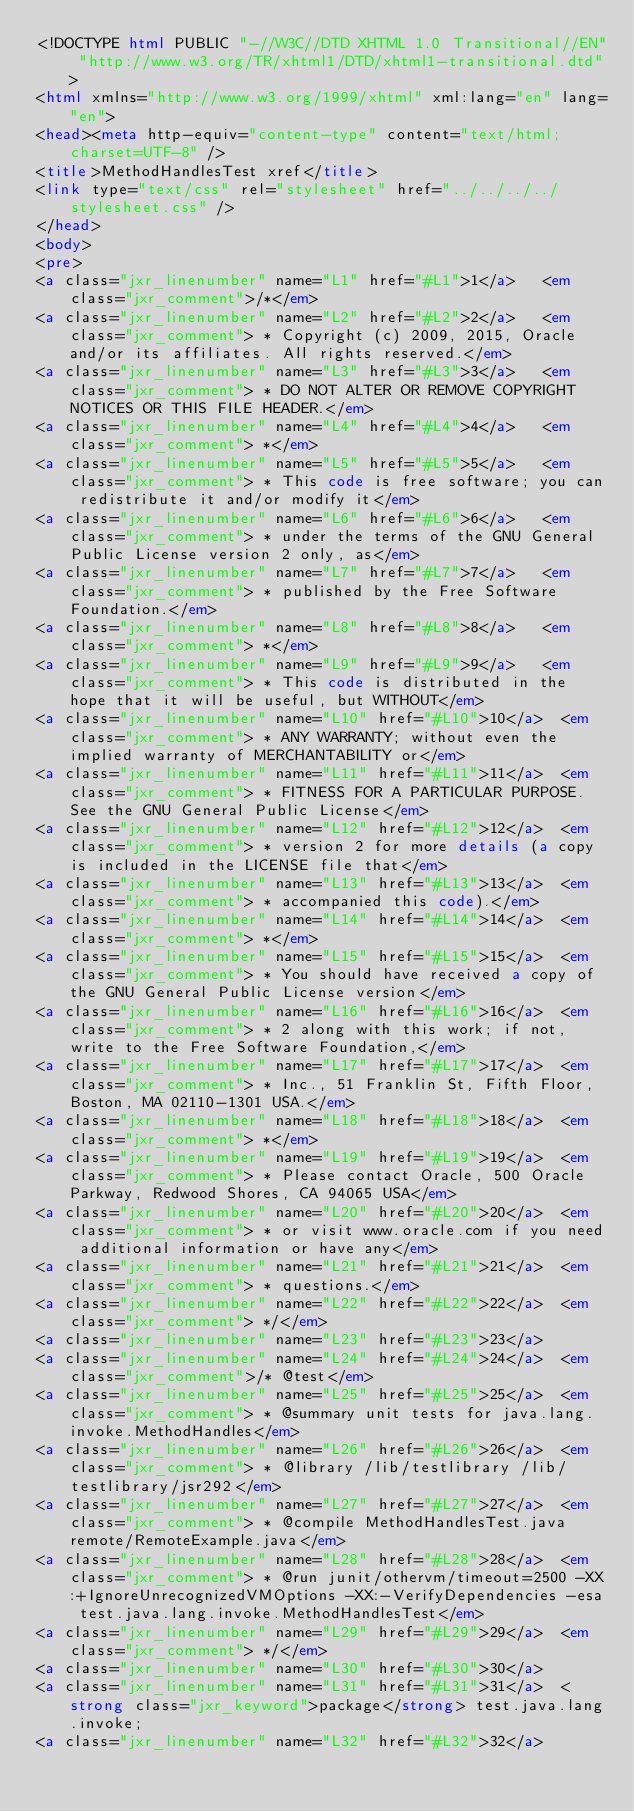Convert code to text. <code><loc_0><loc_0><loc_500><loc_500><_HTML_><!DOCTYPE html PUBLIC "-//W3C//DTD XHTML 1.0 Transitional//EN" "http://www.w3.org/TR/xhtml1/DTD/xhtml1-transitional.dtd">
<html xmlns="http://www.w3.org/1999/xhtml" xml:lang="en" lang="en">
<head><meta http-equiv="content-type" content="text/html; charset=UTF-8" />
<title>MethodHandlesTest xref</title>
<link type="text/css" rel="stylesheet" href="../../../../stylesheet.css" />
</head>
<body>
<pre>
<a class="jxr_linenumber" name="L1" href="#L1">1</a>   <em class="jxr_comment">/*</em>
<a class="jxr_linenumber" name="L2" href="#L2">2</a>   <em class="jxr_comment"> * Copyright (c) 2009, 2015, Oracle and/or its affiliates. All rights reserved.</em>
<a class="jxr_linenumber" name="L3" href="#L3">3</a>   <em class="jxr_comment"> * DO NOT ALTER OR REMOVE COPYRIGHT NOTICES OR THIS FILE HEADER.</em>
<a class="jxr_linenumber" name="L4" href="#L4">4</a>   <em class="jxr_comment"> *</em>
<a class="jxr_linenumber" name="L5" href="#L5">5</a>   <em class="jxr_comment"> * This code is free software; you can redistribute it and/or modify it</em>
<a class="jxr_linenumber" name="L6" href="#L6">6</a>   <em class="jxr_comment"> * under the terms of the GNU General Public License version 2 only, as</em>
<a class="jxr_linenumber" name="L7" href="#L7">7</a>   <em class="jxr_comment"> * published by the Free Software Foundation.</em>
<a class="jxr_linenumber" name="L8" href="#L8">8</a>   <em class="jxr_comment"> *</em>
<a class="jxr_linenumber" name="L9" href="#L9">9</a>   <em class="jxr_comment"> * This code is distributed in the hope that it will be useful, but WITHOUT</em>
<a class="jxr_linenumber" name="L10" href="#L10">10</a>  <em class="jxr_comment"> * ANY WARRANTY; without even the implied warranty of MERCHANTABILITY or</em>
<a class="jxr_linenumber" name="L11" href="#L11">11</a>  <em class="jxr_comment"> * FITNESS FOR A PARTICULAR PURPOSE.  See the GNU General Public License</em>
<a class="jxr_linenumber" name="L12" href="#L12">12</a>  <em class="jxr_comment"> * version 2 for more details (a copy is included in the LICENSE file that</em>
<a class="jxr_linenumber" name="L13" href="#L13">13</a>  <em class="jxr_comment"> * accompanied this code).</em>
<a class="jxr_linenumber" name="L14" href="#L14">14</a>  <em class="jxr_comment"> *</em>
<a class="jxr_linenumber" name="L15" href="#L15">15</a>  <em class="jxr_comment"> * You should have received a copy of the GNU General Public License version</em>
<a class="jxr_linenumber" name="L16" href="#L16">16</a>  <em class="jxr_comment"> * 2 along with this work; if not, write to the Free Software Foundation,</em>
<a class="jxr_linenumber" name="L17" href="#L17">17</a>  <em class="jxr_comment"> * Inc., 51 Franklin St, Fifth Floor, Boston, MA 02110-1301 USA.</em>
<a class="jxr_linenumber" name="L18" href="#L18">18</a>  <em class="jxr_comment"> *</em>
<a class="jxr_linenumber" name="L19" href="#L19">19</a>  <em class="jxr_comment"> * Please contact Oracle, 500 Oracle Parkway, Redwood Shores, CA 94065 USA</em>
<a class="jxr_linenumber" name="L20" href="#L20">20</a>  <em class="jxr_comment"> * or visit www.oracle.com if you need additional information or have any</em>
<a class="jxr_linenumber" name="L21" href="#L21">21</a>  <em class="jxr_comment"> * questions.</em>
<a class="jxr_linenumber" name="L22" href="#L22">22</a>  <em class="jxr_comment"> */</em>
<a class="jxr_linenumber" name="L23" href="#L23">23</a>  
<a class="jxr_linenumber" name="L24" href="#L24">24</a>  <em class="jxr_comment">/* @test</em>
<a class="jxr_linenumber" name="L25" href="#L25">25</a>  <em class="jxr_comment"> * @summary unit tests for java.lang.invoke.MethodHandles</em>
<a class="jxr_linenumber" name="L26" href="#L26">26</a>  <em class="jxr_comment"> * @library /lib/testlibrary /lib/testlibrary/jsr292</em>
<a class="jxr_linenumber" name="L27" href="#L27">27</a>  <em class="jxr_comment"> * @compile MethodHandlesTest.java remote/RemoteExample.java</em>
<a class="jxr_linenumber" name="L28" href="#L28">28</a>  <em class="jxr_comment"> * @run junit/othervm/timeout=2500 -XX:+IgnoreUnrecognizedVMOptions -XX:-VerifyDependencies -esa test.java.lang.invoke.MethodHandlesTest</em>
<a class="jxr_linenumber" name="L29" href="#L29">29</a>  <em class="jxr_comment"> */</em>
<a class="jxr_linenumber" name="L30" href="#L30">30</a>  
<a class="jxr_linenumber" name="L31" href="#L31">31</a>  <strong class="jxr_keyword">package</strong> test.java.lang.invoke;
<a class="jxr_linenumber" name="L32" href="#L32">32</a>  </code> 